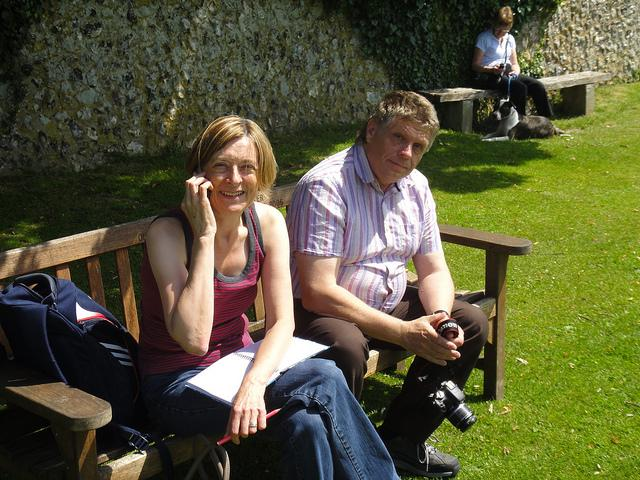What is the woman wearing sleeveless shirt doing?

Choices:
A) recording
B) taking photo
C) using phone
D) itching using phone 